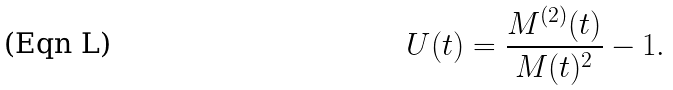Convert formula to latex. <formula><loc_0><loc_0><loc_500><loc_500>U ( t ) = \frac { M ^ { ( 2 ) } ( t ) } { M ( t ) ^ { 2 } } - 1 .</formula> 